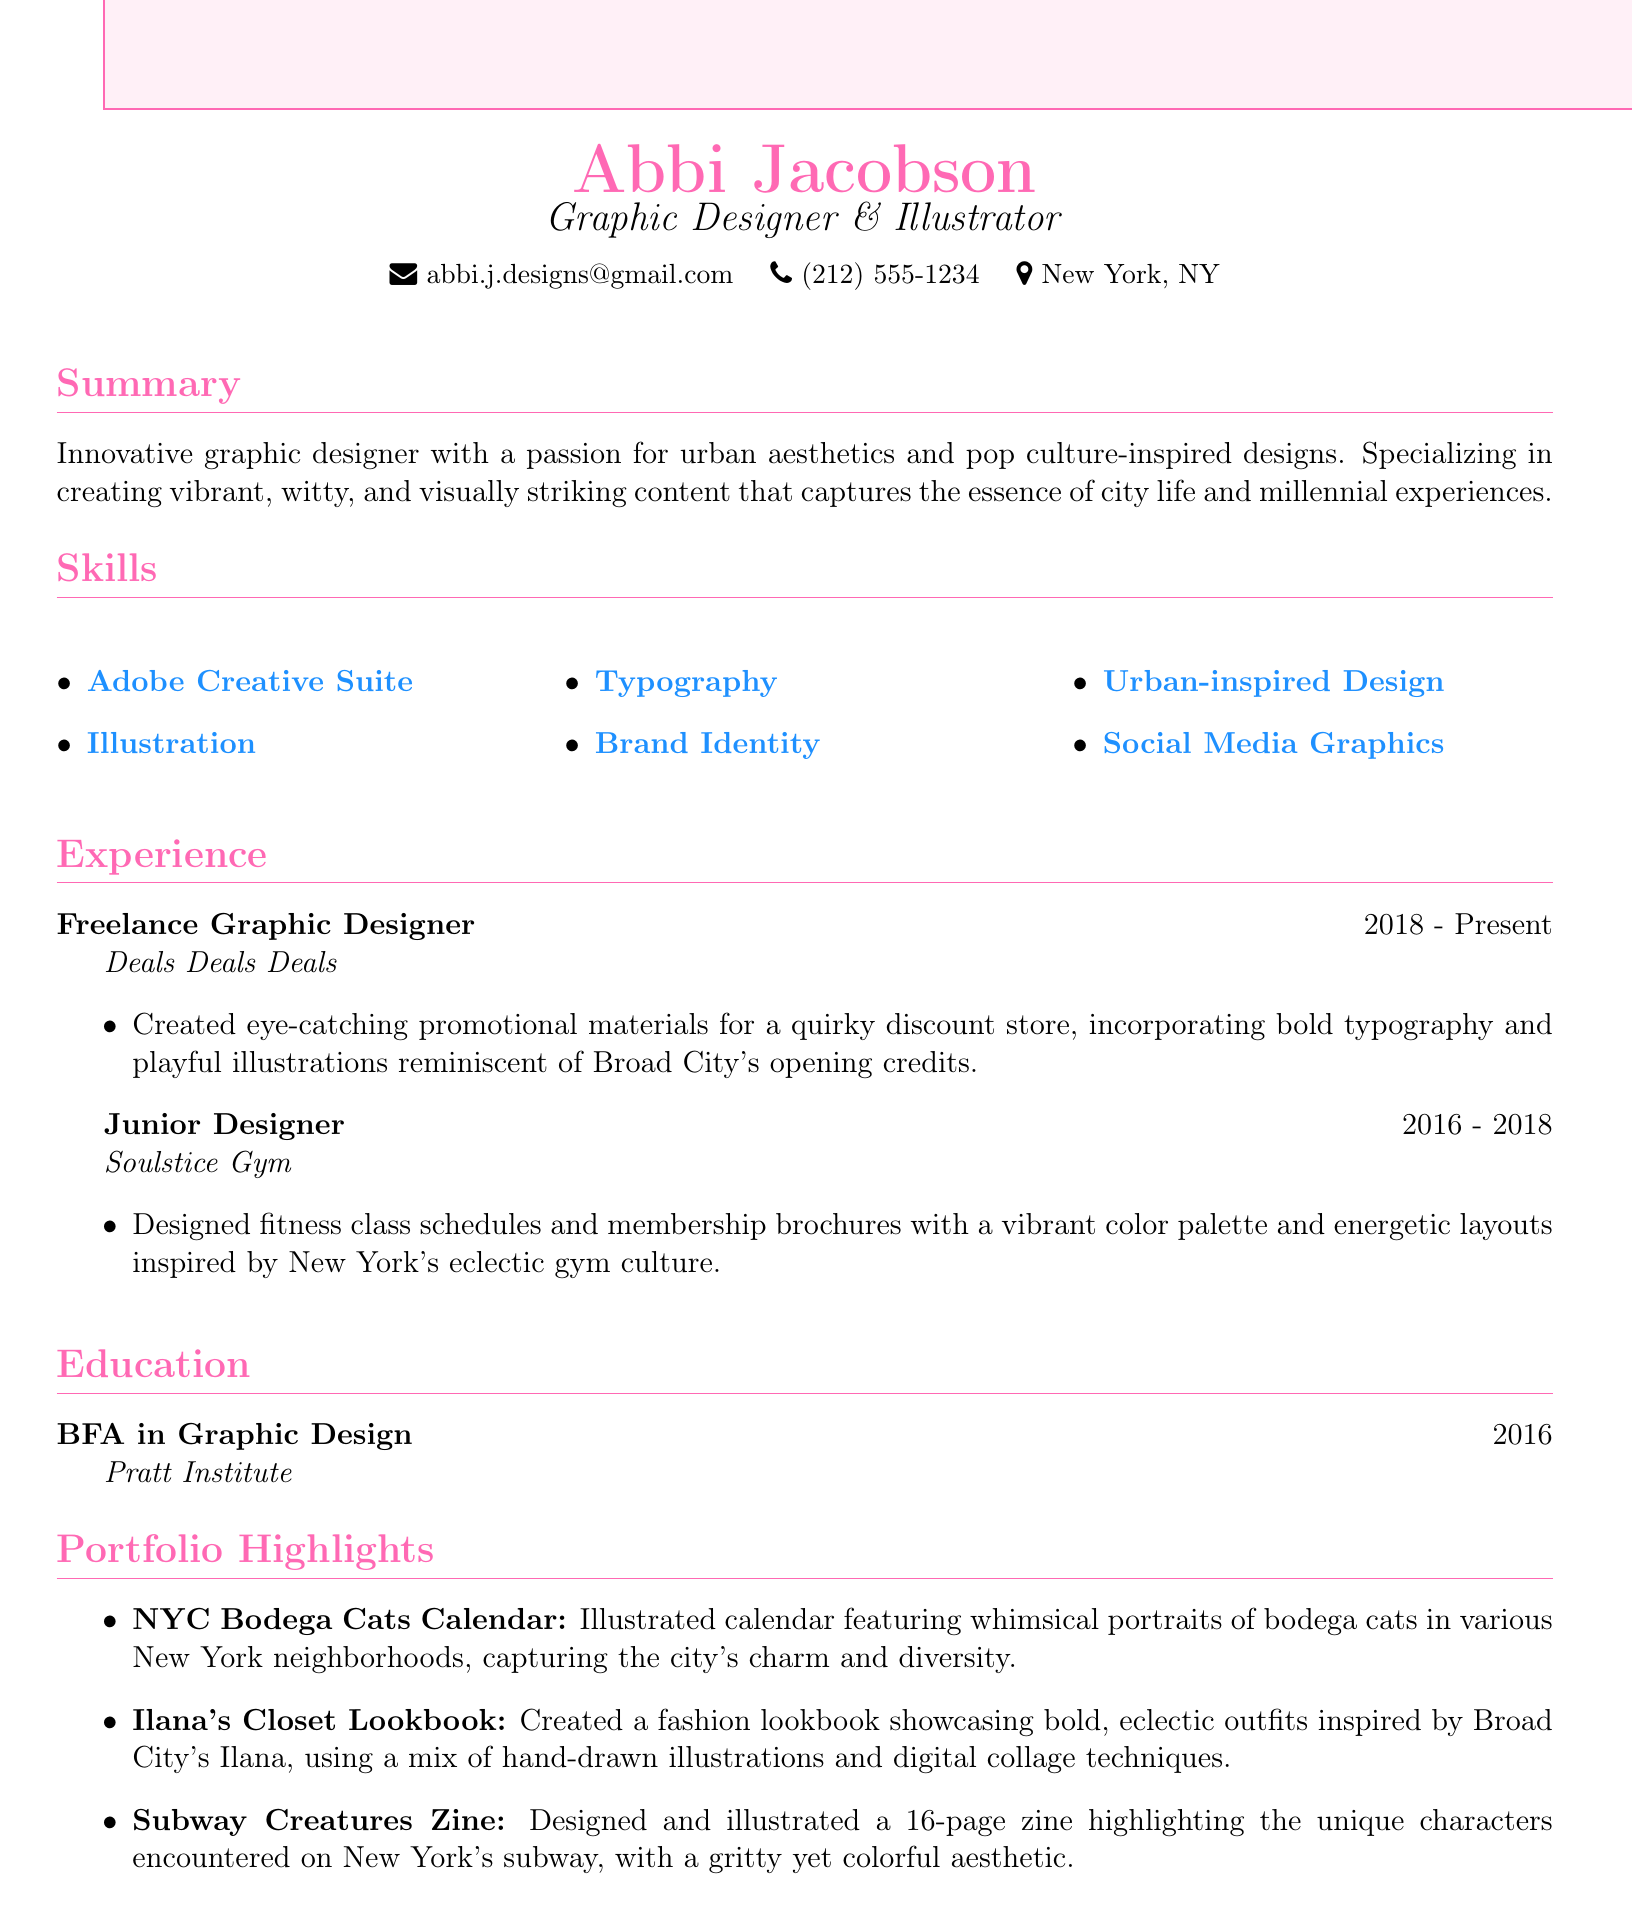What is the designer's name? The document states the designer's name at the top.
Answer: Abbi Jacobson What is the designer's email? The email is provided in the personal info section of the document.
Answer: abbi.j.designs@gmail.com What degree did the designer earn? The education section indicates the designer's academic qualification.
Answer: BFA in Graphic Design What company did the designer work for as a Junior Designer? The experience section lists the companies where the designer worked.
Answer: Soulstice Gym What project features whimsical portraits of cats? The portfolio section describes various projects, one of which includes cats.
Answer: NYC Bodega Cats Calendar Which aesthetics inspire the designer's work? The summary highlights the designer's influences and themes in their designs.
Answer: Urban aesthetics and pop culture How long has the designer been a Freelance Graphic Designer? The duration listed in the experience section shows the time frame for this role.
Answer: 2018 - Present What type of graphics does the designer specialize in? The skills section lists specific areas of expertise for the designer.
Answer: Social Media Graphics What color scheme does the document use for the title? The title format section outlines the color used for the designer's name.
Answer: Primary color (HTML: FF69B4) 